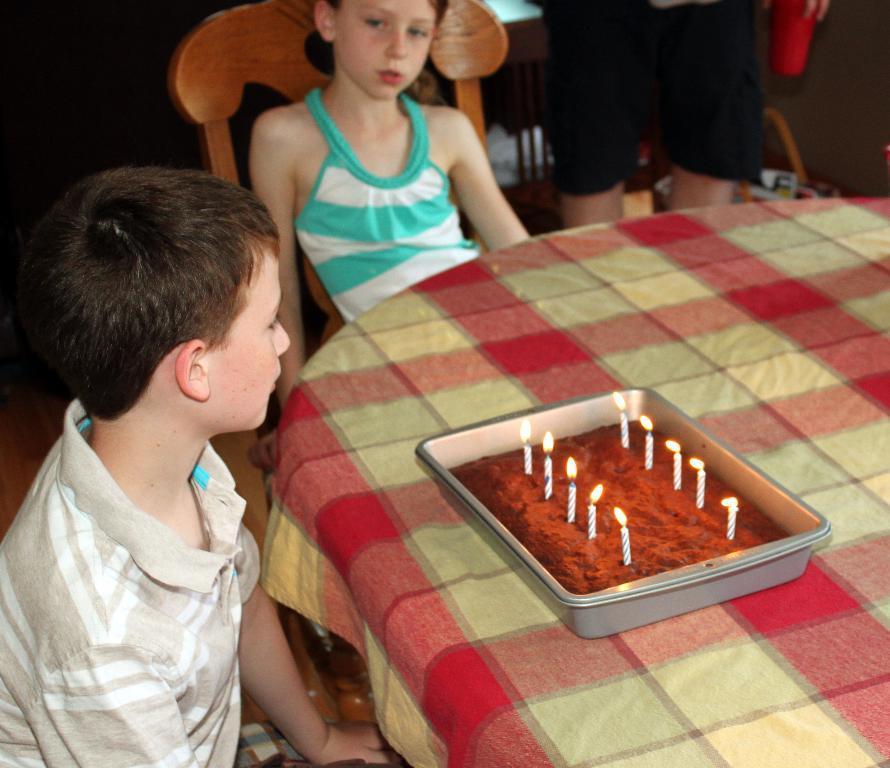Could you give a brief overview of what you see in this image? This is the picture taken in a room, there are kids sitting on chair in front of these people there is a table on the table there are food on tray and candles. Background of these people is a man is standing. 